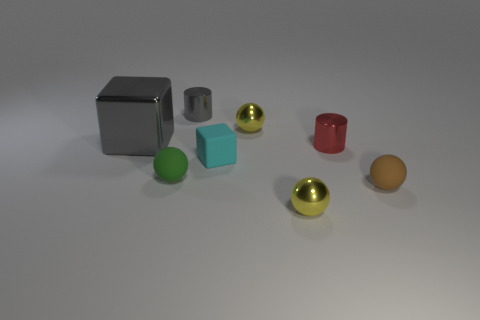Do the metallic cube and the small block have the same color?
Offer a terse response. No. Are there fewer tiny brown spheres than big blue rubber blocks?
Make the answer very short. No. Are the tiny sphere behind the red metallic object and the small cylinder that is to the left of the tiny cyan matte object made of the same material?
Offer a terse response. Yes. Are there fewer tiny things that are behind the green thing than small objects?
Provide a succinct answer. Yes. There is a gray shiny thing behind the gray cube; what number of small matte spheres are to the right of it?
Provide a short and direct response. 1. What is the size of the object that is behind the big gray cube and in front of the gray metallic cylinder?
Keep it short and to the point. Small. Are the gray block and the tiny yellow thing in front of the tiny cyan rubber thing made of the same material?
Keep it short and to the point. Yes. Are there fewer tiny red metal objects that are right of the small cyan block than objects in front of the tiny gray metallic object?
Provide a short and direct response. Yes. What material is the tiny green ball on the left side of the brown rubber object?
Your response must be concise. Rubber. What color is the thing that is both on the left side of the gray cylinder and in front of the big gray block?
Offer a very short reply. Green. 